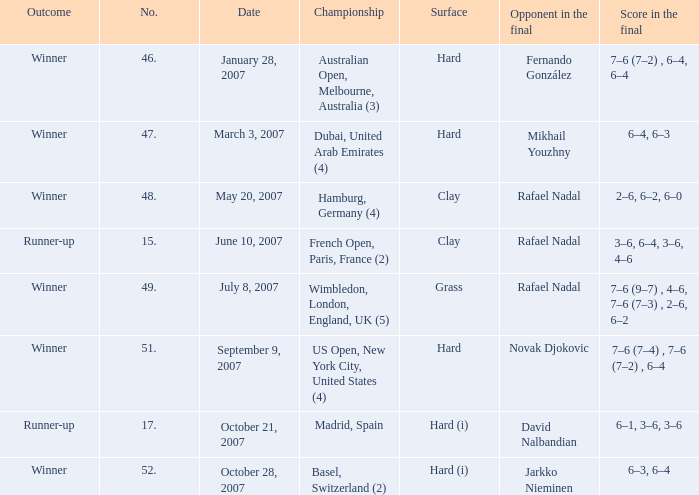For the date 10/21/2007, what is the associated number? 17.0. 